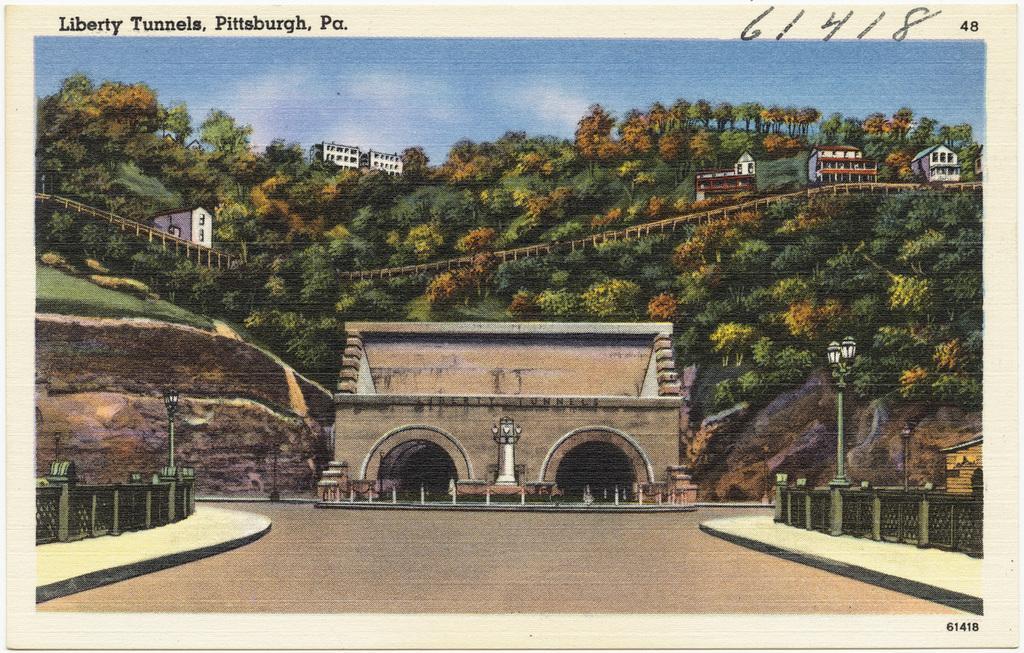Can you describe this image briefly? At the top and bottom portion of the picture we can see the information. In this picture we can see the buildings, trees, grass, fence, light poles. On the left and right side of the picture we can see the railings. 